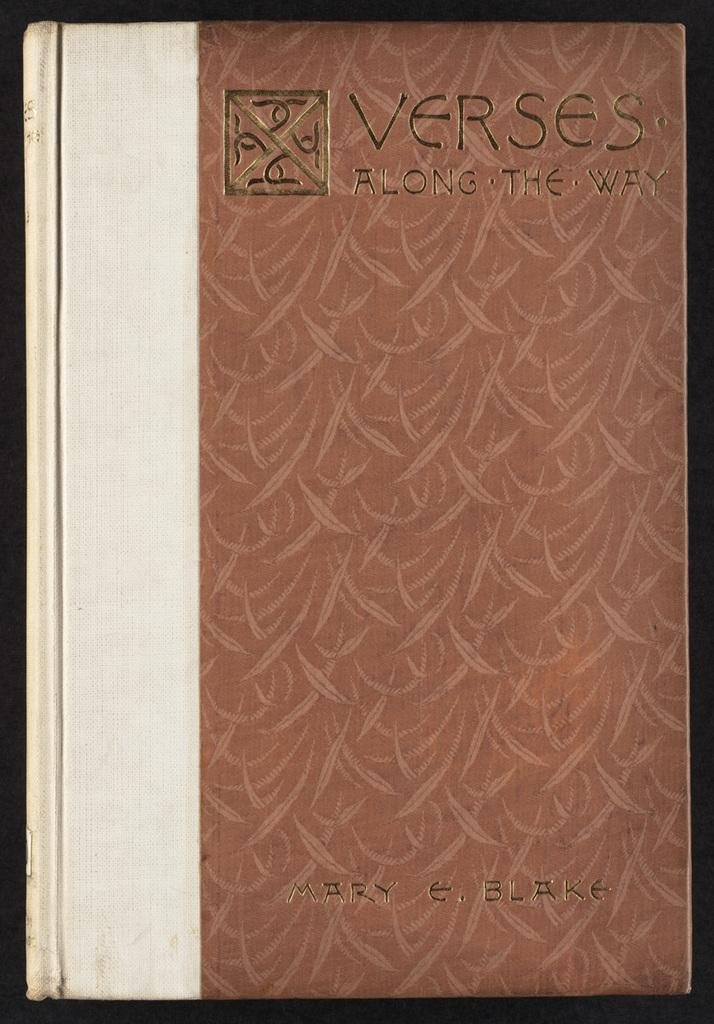<image>
Write a terse but informative summary of the picture. A hardcover copy of Verses Along the Way by Mary Blake. 